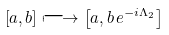<formula> <loc_0><loc_0><loc_500><loc_500>\left [ a , b \right ] \longmapsto \left [ a , b \, e ^ { - i \Lambda _ { 2 } } \right ]</formula> 